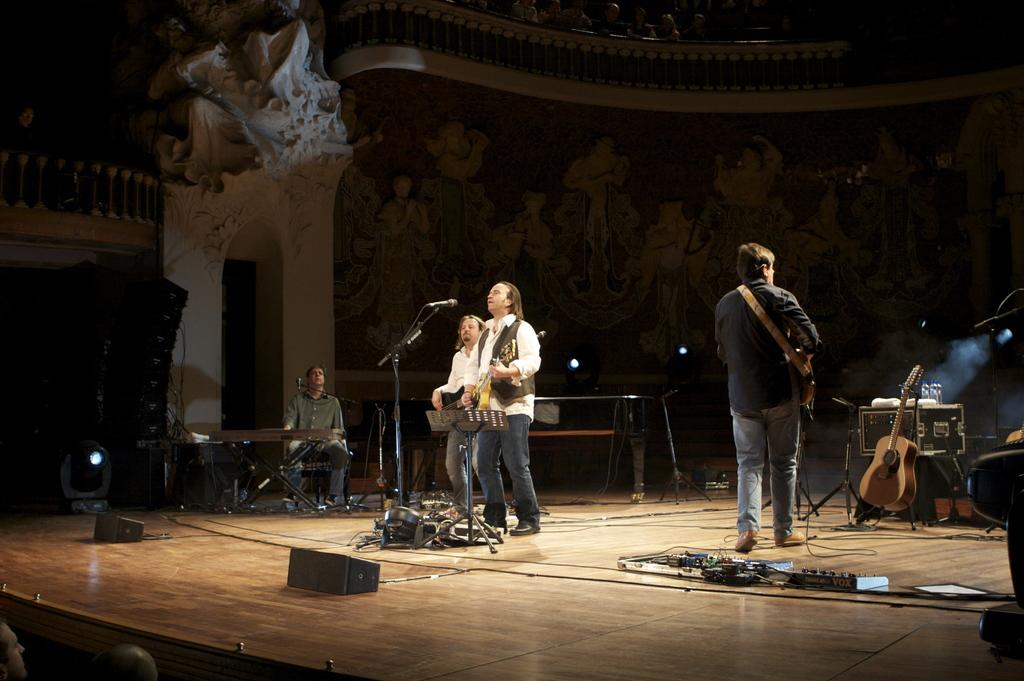What type of structure can be seen in the image? There is a wall in the image. How many people are on stage in the image? There are four people on stage in the image. What musical instruments are present in the image? Guitars, musical keyboards, and microphones are visible in the image. Are there any wires in the image? Yes, there are wires in the image. What is located on the left side of the image? There is a fence on the left side of the image. How many tails can be seen on the people on stage in the image? There are no tails visible on the people on stage in the image. What is the range of the musical instruments in the image? The range of the musical instruments cannot be determined from the image alone, as it depends on the specific instruments and their capabilities. 